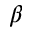Convert formula to latex. <formula><loc_0><loc_0><loc_500><loc_500>\beta</formula> 